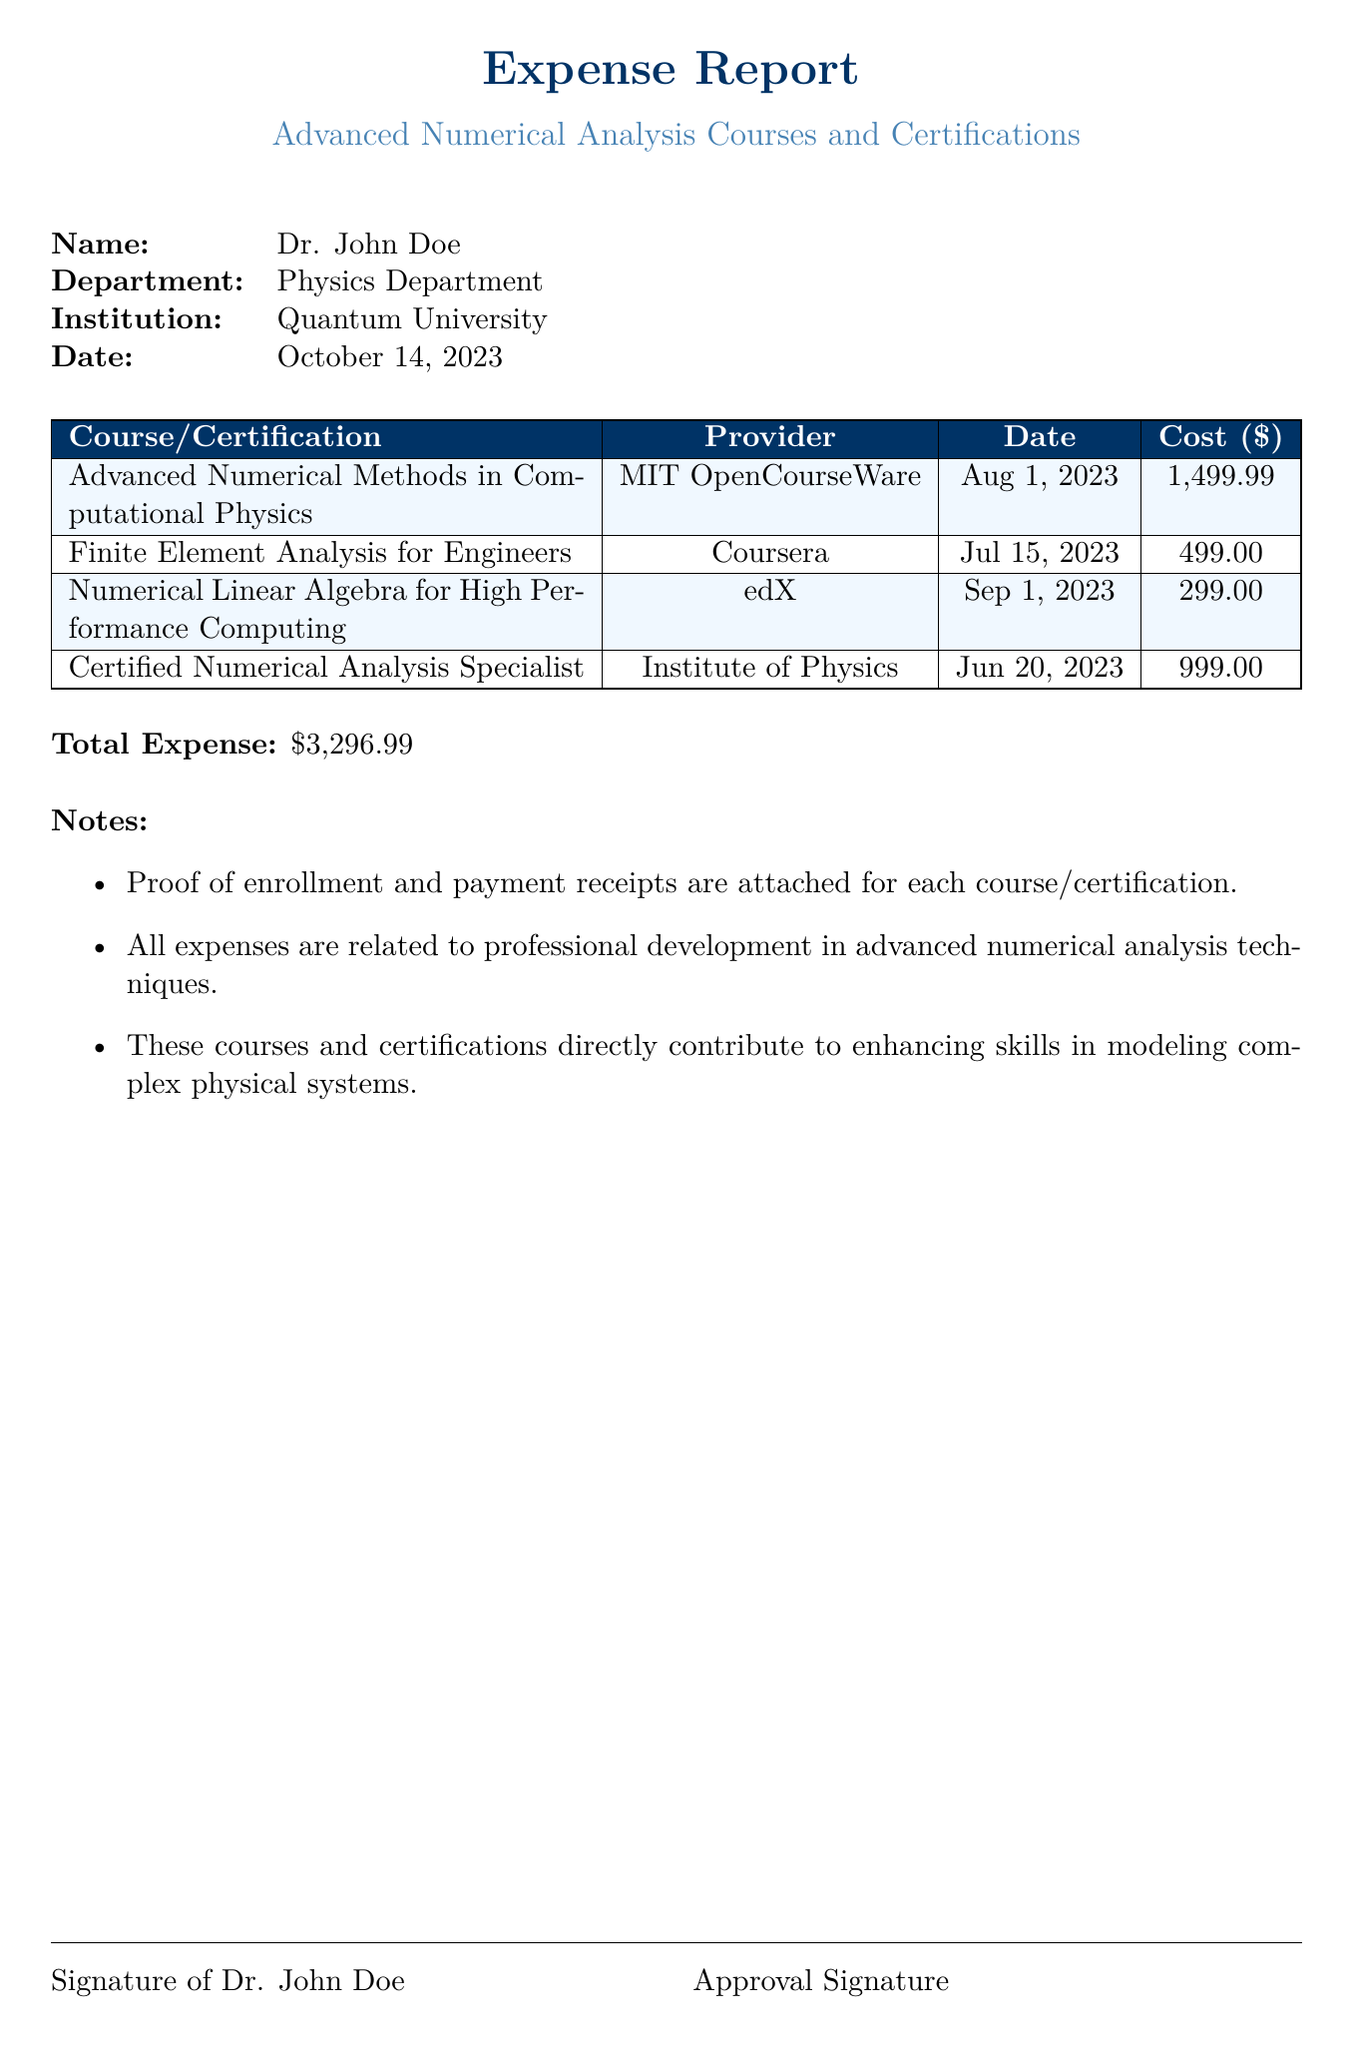What is the total expense? The total expense is the sum of all course costs listed in the document, which equals $3,296.99.
Answer: $3,296.99 Who is the report for? The report is prepared for Dr. John Doe, as indicated at the top of the document.
Answer: Dr. John Doe What is the date of the report? The date of the report is mentioned in the document as October 14, 2023.
Answer: October 14, 2023 Which provider offered the course on Advanced Numerical Methods in Computational Physics? The provider for this course is listed as MIT OpenCourseWare.
Answer: MIT OpenCourseWare How many courses are included in the report? The document lists four courses and certifications related to professional development.
Answer: Four What is the cost of the Certified Numerical Analysis Specialist course? The cost listed for this specific course is $999.00.
Answer: $999.00 What type of courses are detailed in the report? The courses are focused on advanced numerical analysis as part of professional development.
Answer: Advanced numerical analysis What are the attachments mentioned in the notes? The notes state that proof of enrollment and payment receipts are attached for each course or certification.
Answer: Proof of enrollment and payment receipts What is the name of the institution? The name of the institution in the report is Quantum University.
Answer: Quantum University 